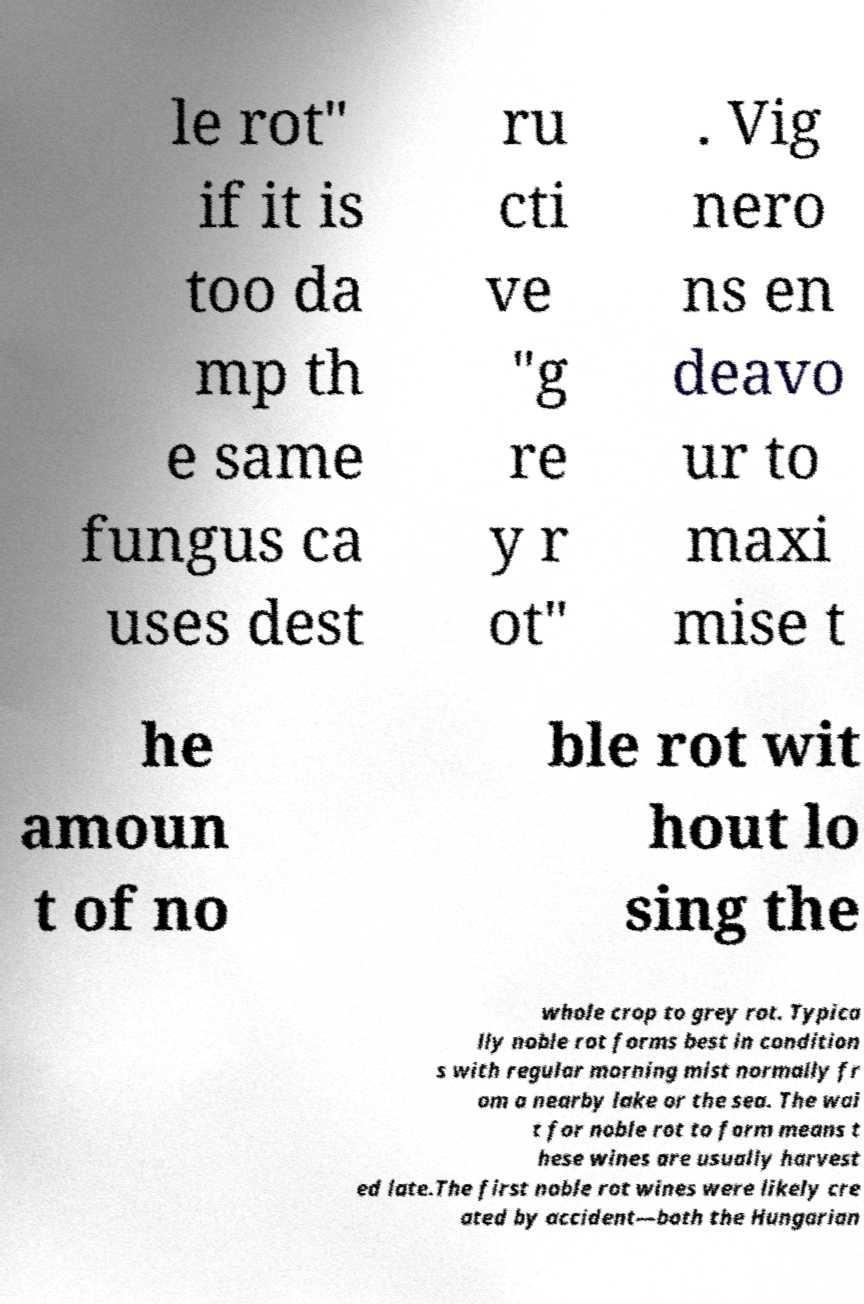Please read and relay the text visible in this image. What does it say? le rot" if it is too da mp th e same fungus ca uses dest ru cti ve "g re y r ot" . Vig nero ns en deavo ur to maxi mise t he amoun t of no ble rot wit hout lo sing the whole crop to grey rot. Typica lly noble rot forms best in condition s with regular morning mist normally fr om a nearby lake or the sea. The wai t for noble rot to form means t hese wines are usually harvest ed late.The first noble rot wines were likely cre ated by accident—both the Hungarian 